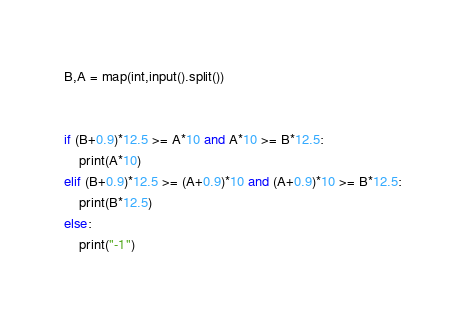Convert code to text. <code><loc_0><loc_0><loc_500><loc_500><_Python_>B,A = map(int,input().split())


if (B+0.9)*12.5 >= A*10 and A*10 >= B*12.5:
    print(A*10)
elif (B+0.9)*12.5 >= (A+0.9)*10 and (A+0.9)*10 >= B*12.5:
    print(B*12.5)
else:
    print("-1")</code> 